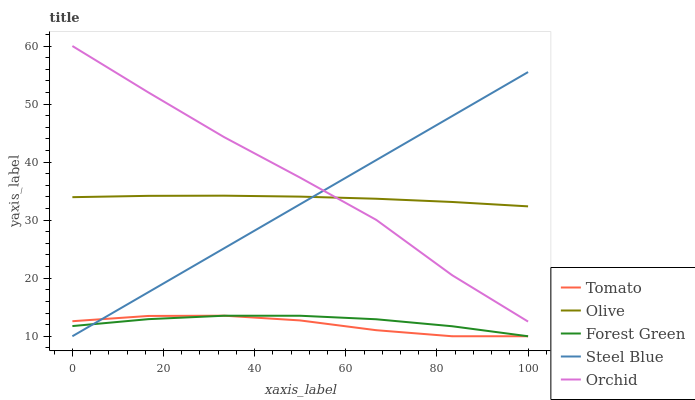Does Tomato have the minimum area under the curve?
Answer yes or no. Yes. Does Orchid have the maximum area under the curve?
Answer yes or no. Yes. Does Olive have the minimum area under the curve?
Answer yes or no. No. Does Olive have the maximum area under the curve?
Answer yes or no. No. Is Steel Blue the smoothest?
Answer yes or no. Yes. Is Orchid the roughest?
Answer yes or no. Yes. Is Olive the smoothest?
Answer yes or no. No. Is Olive the roughest?
Answer yes or no. No. Does Olive have the lowest value?
Answer yes or no. No. Does Olive have the highest value?
Answer yes or no. No. Is Forest Green less than Orchid?
Answer yes or no. Yes. Is Orchid greater than Tomato?
Answer yes or no. Yes. Does Forest Green intersect Orchid?
Answer yes or no. No. 